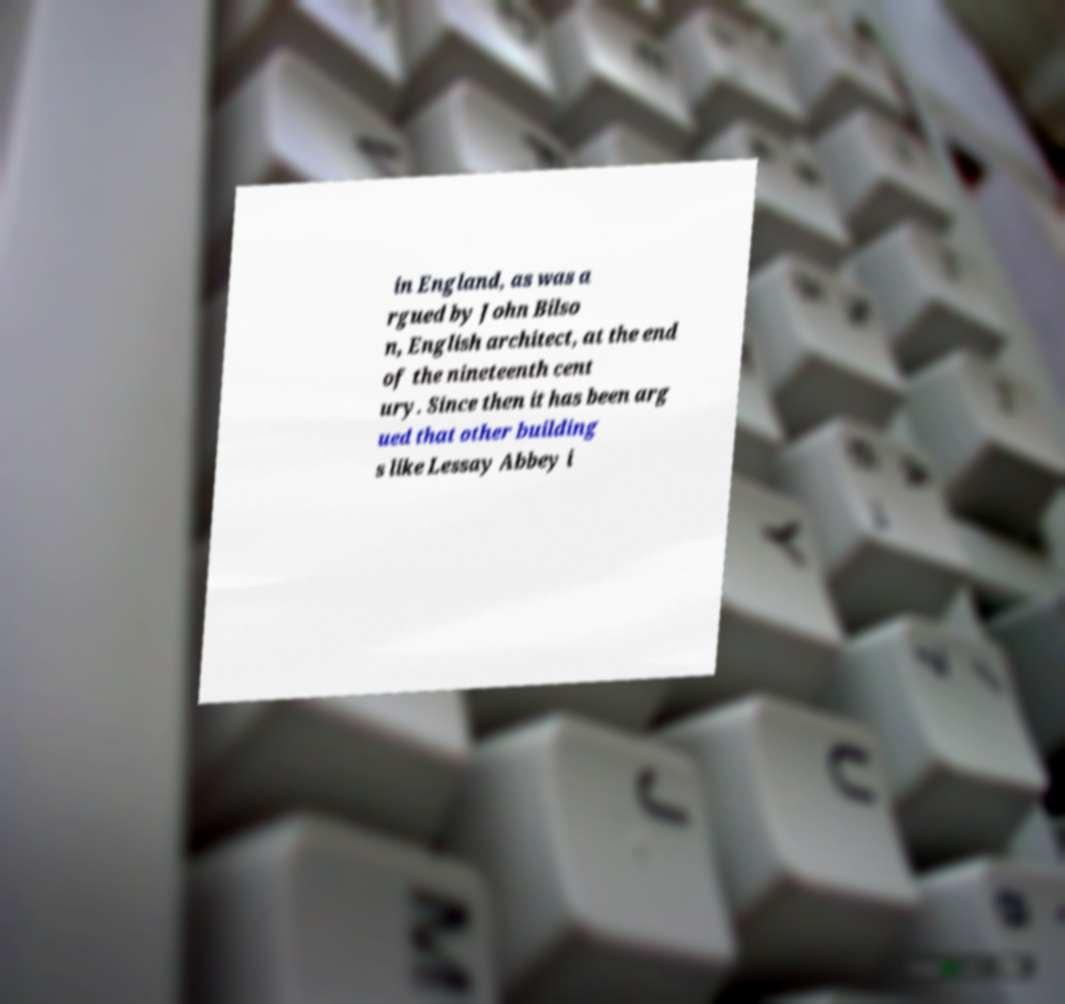Could you extract and type out the text from this image? in England, as was a rgued by John Bilso n, English architect, at the end of the nineteenth cent ury. Since then it has been arg ued that other building s like Lessay Abbey i 